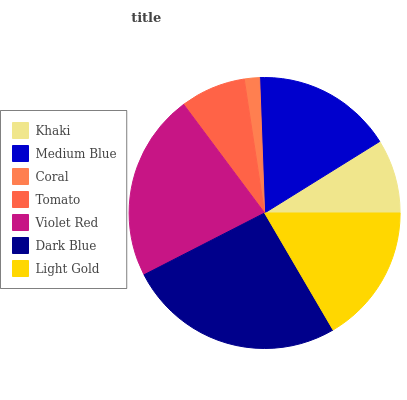Is Coral the minimum?
Answer yes or no. Yes. Is Dark Blue the maximum?
Answer yes or no. Yes. Is Medium Blue the minimum?
Answer yes or no. No. Is Medium Blue the maximum?
Answer yes or no. No. Is Medium Blue greater than Khaki?
Answer yes or no. Yes. Is Khaki less than Medium Blue?
Answer yes or no. Yes. Is Khaki greater than Medium Blue?
Answer yes or no. No. Is Medium Blue less than Khaki?
Answer yes or no. No. Is Light Gold the high median?
Answer yes or no. Yes. Is Light Gold the low median?
Answer yes or no. Yes. Is Dark Blue the high median?
Answer yes or no. No. Is Dark Blue the low median?
Answer yes or no. No. 